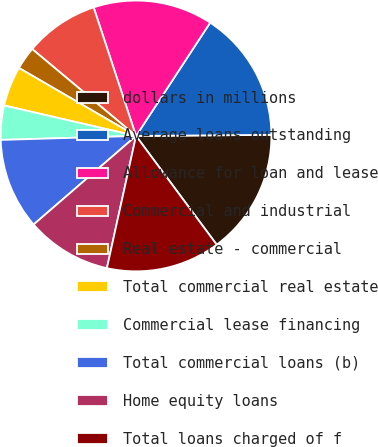Convert chart to OTSL. <chart><loc_0><loc_0><loc_500><loc_500><pie_chart><fcel>dollars in millions<fcel>Average loans outstanding<fcel>Allowance for loan and lease<fcel>Commercial and industrial<fcel>Real estate - commercial<fcel>Total commercial real estate<fcel>Commercial lease financing<fcel>Total commercial loans (b)<fcel>Home equity loans<fcel>Total loans charged of f<nl><fcel>14.97%<fcel>15.65%<fcel>14.29%<fcel>8.84%<fcel>2.72%<fcel>4.76%<fcel>4.08%<fcel>10.88%<fcel>10.2%<fcel>13.61%<nl></chart> 